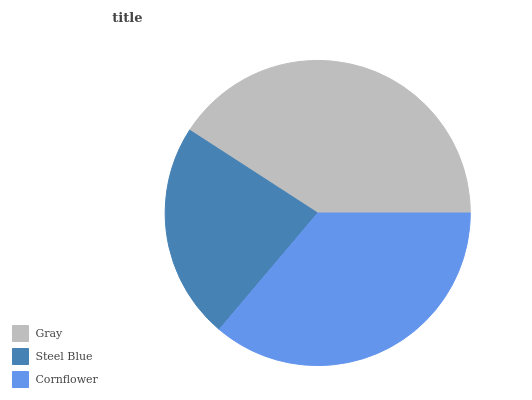Is Steel Blue the minimum?
Answer yes or no. Yes. Is Gray the maximum?
Answer yes or no. Yes. Is Cornflower the minimum?
Answer yes or no. No. Is Cornflower the maximum?
Answer yes or no. No. Is Cornflower greater than Steel Blue?
Answer yes or no. Yes. Is Steel Blue less than Cornflower?
Answer yes or no. Yes. Is Steel Blue greater than Cornflower?
Answer yes or no. No. Is Cornflower less than Steel Blue?
Answer yes or no. No. Is Cornflower the high median?
Answer yes or no. Yes. Is Cornflower the low median?
Answer yes or no. Yes. Is Steel Blue the high median?
Answer yes or no. No. Is Gray the low median?
Answer yes or no. No. 